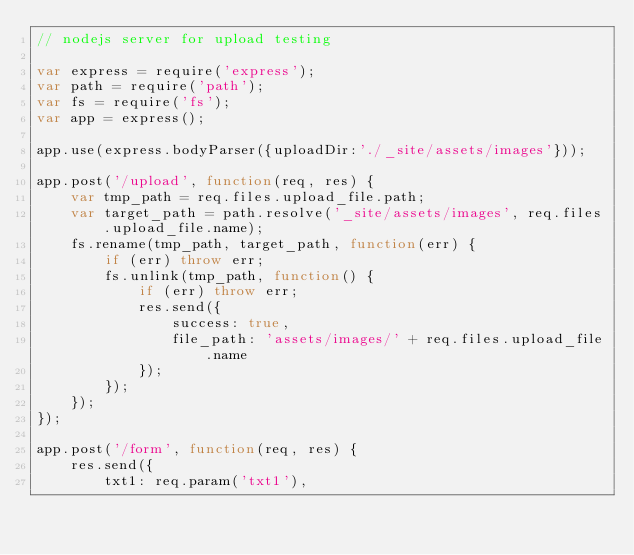<code> <loc_0><loc_0><loc_500><loc_500><_JavaScript_>// nodejs server for upload testing

var express = require('express');
var path = require('path');
var fs = require('fs');
var app = express();

app.use(express.bodyParser({uploadDir:'./_site/assets/images'}));

app.post('/upload', function(req, res) {
    var tmp_path = req.files.upload_file.path;
    var target_path = path.resolve('_site/assets/images', req.files.upload_file.name);
    fs.rename(tmp_path, target_path, function(err) {
        if (err) throw err;
        fs.unlink(tmp_path, function() {
            if (err) throw err;
            res.send({
                success: true,
                file_path: 'assets/images/' + req.files.upload_file.name
            });
        });
    });
});

app.post('/form', function(req, res) {
    res.send({
        txt1: req.param('txt1'),</code> 